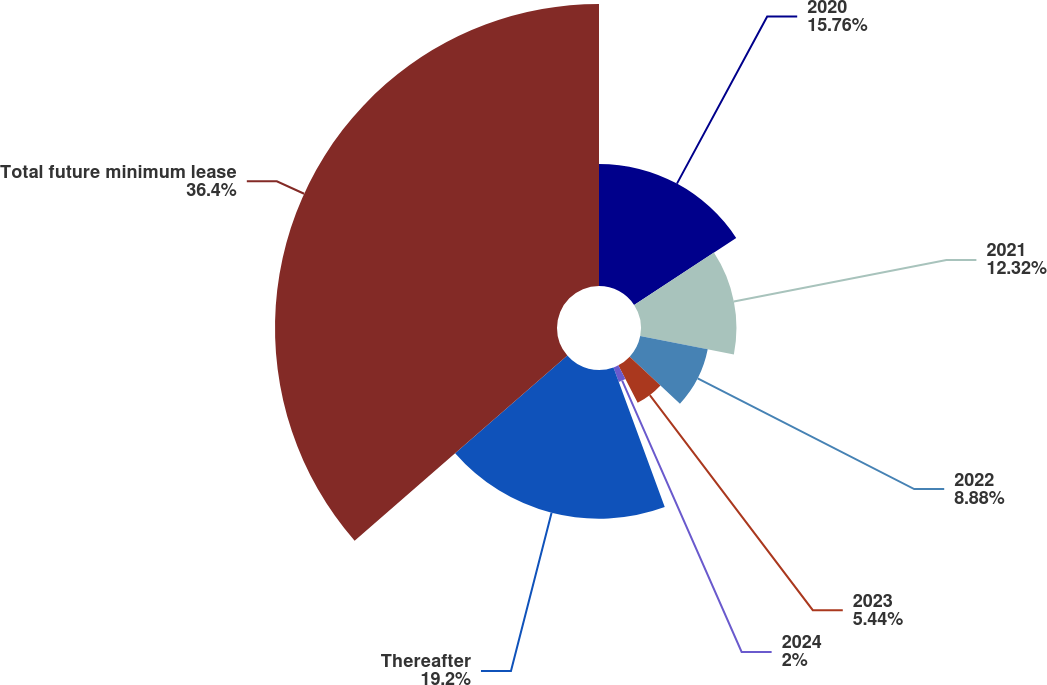<chart> <loc_0><loc_0><loc_500><loc_500><pie_chart><fcel>2020<fcel>2021<fcel>2022<fcel>2023<fcel>2024<fcel>Thereafter<fcel>Total future minimum lease<nl><fcel>15.76%<fcel>12.32%<fcel>8.88%<fcel>5.44%<fcel>2.0%<fcel>19.2%<fcel>36.4%<nl></chart> 